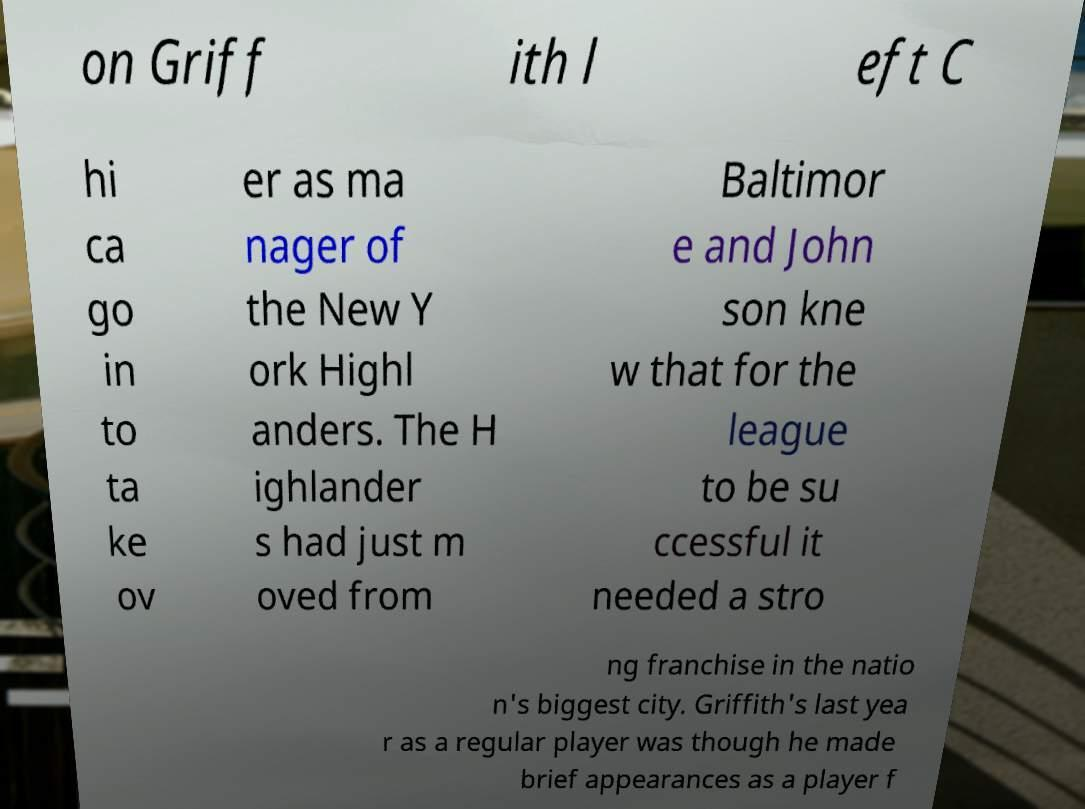What messages or text are displayed in this image? I need them in a readable, typed format. on Griff ith l eft C hi ca go in to ta ke ov er as ma nager of the New Y ork Highl anders. The H ighlander s had just m oved from Baltimor e and John son kne w that for the league to be su ccessful it needed a stro ng franchise in the natio n's biggest city. Griffith's last yea r as a regular player was though he made brief appearances as a player f 